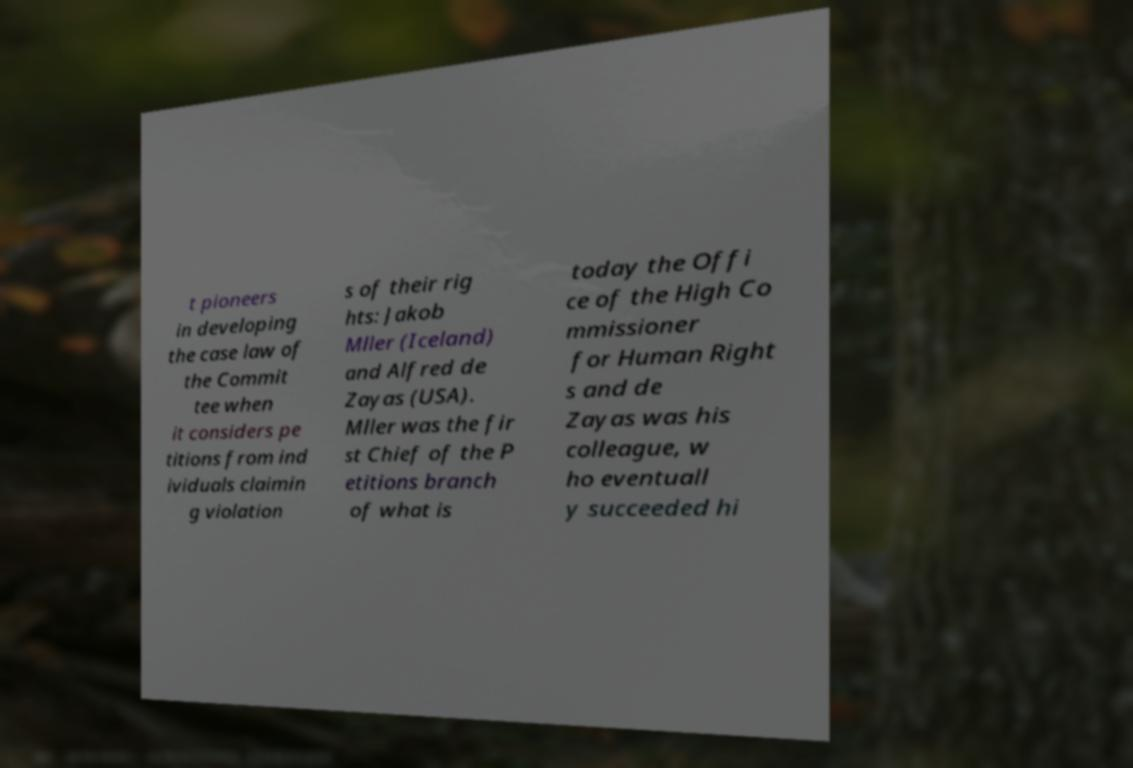I need the written content from this picture converted into text. Can you do that? t pioneers in developing the case law of the Commit tee when it considers pe titions from ind ividuals claimin g violation s of their rig hts: Jakob Mller (Iceland) and Alfred de Zayas (USA). Mller was the fir st Chief of the P etitions branch of what is today the Offi ce of the High Co mmissioner for Human Right s and de Zayas was his colleague, w ho eventuall y succeeded hi 